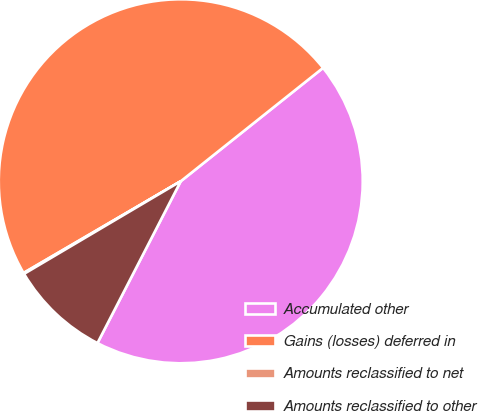<chart> <loc_0><loc_0><loc_500><loc_500><pie_chart><fcel>Accumulated other<fcel>Gains (losses) deferred in<fcel>Amounts reclassified to net<fcel>Amounts reclassified to other<nl><fcel>43.27%<fcel>47.7%<fcel>0.09%<fcel>8.94%<nl></chart> 